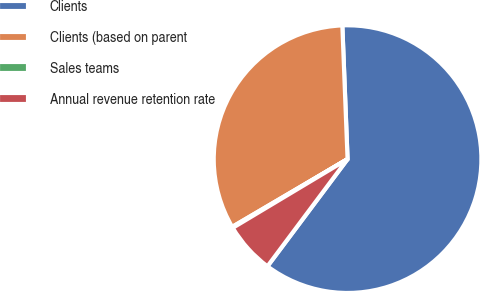Convert chart to OTSL. <chart><loc_0><loc_0><loc_500><loc_500><pie_chart><fcel>Clients<fcel>Clients (based on parent<fcel>Sales teams<fcel>Annual revenue retention rate<nl><fcel>60.84%<fcel>32.83%<fcel>0.13%<fcel>6.2%<nl></chart> 